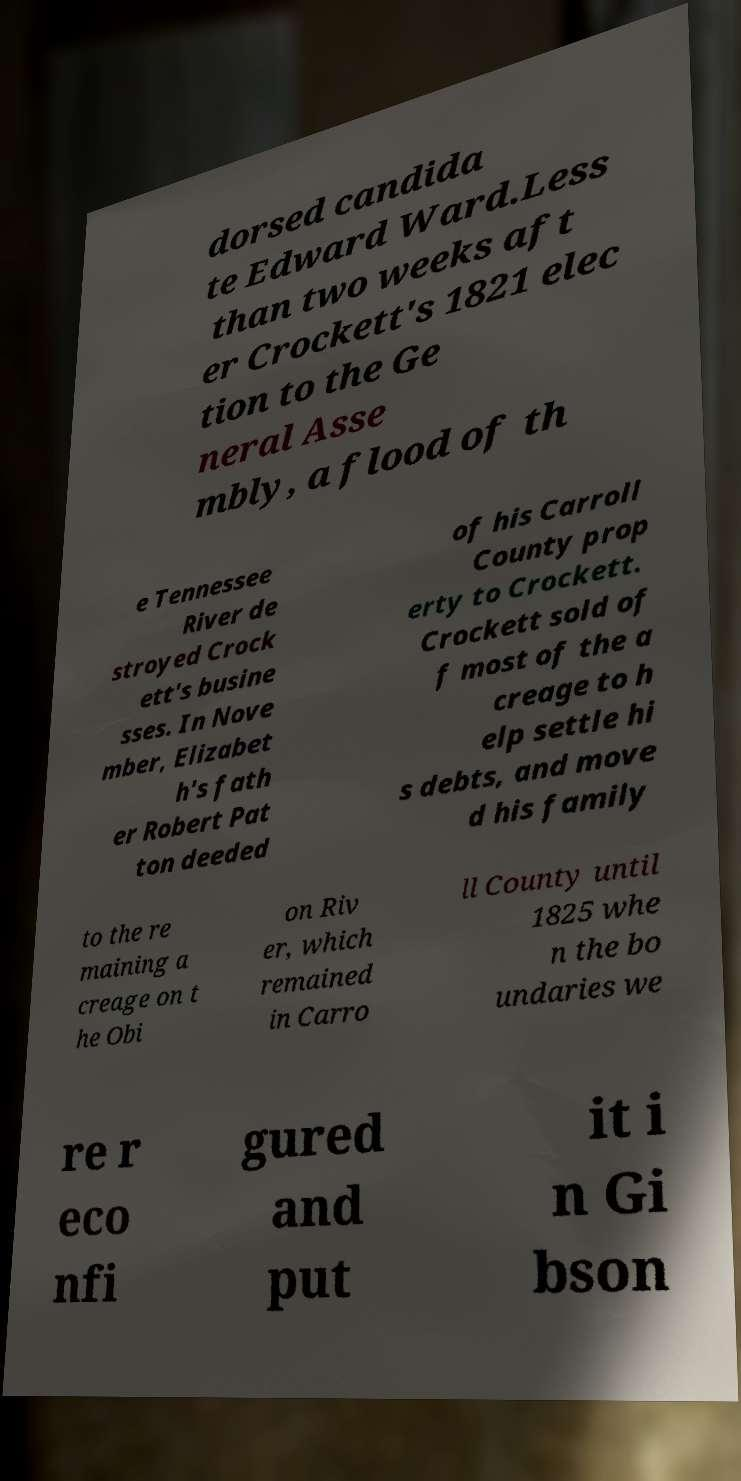Please identify and transcribe the text found in this image. dorsed candida te Edward Ward.Less than two weeks aft er Crockett's 1821 elec tion to the Ge neral Asse mbly, a flood of th e Tennessee River de stroyed Crock ett's busine sses. In Nove mber, Elizabet h's fath er Robert Pat ton deeded of his Carroll County prop erty to Crockett. Crockett sold of f most of the a creage to h elp settle hi s debts, and move d his family to the re maining a creage on t he Obi on Riv er, which remained in Carro ll County until 1825 whe n the bo undaries we re r eco nfi gured and put it i n Gi bson 